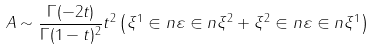Convert formula to latex. <formula><loc_0><loc_0><loc_500><loc_500>A \sim \frac { \Gamma ( - 2 t ) } { \Gamma ( 1 - t ) ^ { 2 } } t ^ { 2 } \left ( \xi ^ { 1 } \in n \varepsilon \in n \xi ^ { 2 } + \xi ^ { 2 } \in n \varepsilon \in n \xi ^ { 1 } \right )</formula> 